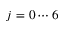<formula> <loc_0><loc_0><loc_500><loc_500>j = 0 \cdots 6</formula> 